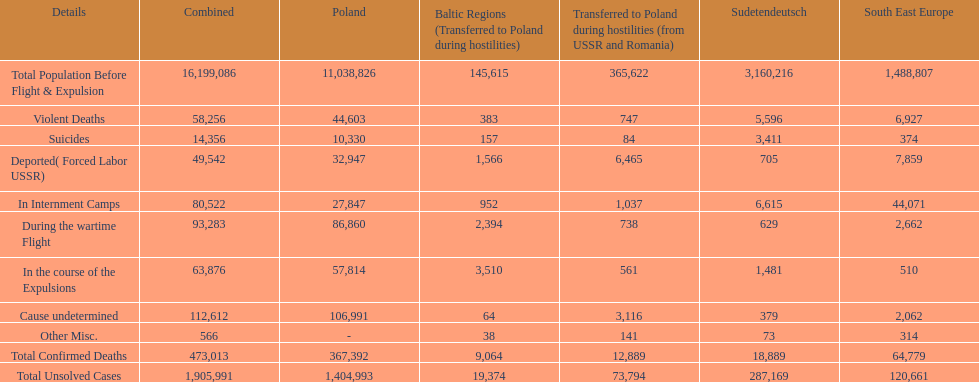Give me the full table as a dictionary. {'header': ['Details', 'Combined', 'Poland', 'Baltic Regions (Transferred to Poland during hostilities)', 'Transferred to Poland during hostilities (from USSR and Romania)', 'Sudetendeutsch', 'South East Europe'], 'rows': [['Total Population Before Flight & Expulsion', '16,199,086', '11,038,826', '145,615', '365,622', '3,160,216', '1,488,807'], ['Violent Deaths', '58,256', '44,603', '383', '747', '5,596', '6,927'], ['Suicides', '14,356', '10,330', '157', '84', '3,411', '374'], ['Deported( Forced Labor USSR)', '49,542', '32,947', '1,566', '6,465', '705', '7,859'], ['In Internment Camps', '80,522', '27,847', '952', '1,037', '6,615', '44,071'], ['During the wartime Flight', '93,283', '86,860', '2,394', '738', '629', '2,662'], ['In the course of the Expulsions', '63,876', '57,814', '3,510', '561', '1,481', '510'], ['Cause undetermined', '112,612', '106,991', '64', '3,116', '379', '2,062'], ['Other Misc.', '566', '-', '38', '141', '73', '314'], ['Total Confirmed Deaths', '473,013', '367,392', '9,064', '12,889', '18,889', '64,779'], ['Total Unsolved Cases', '1,905,991', '1,404,993', '19,374', '73,794', '287,169', '120,661']]} What is the total of deaths in internment camps and during the wartime flight? 173,805. 